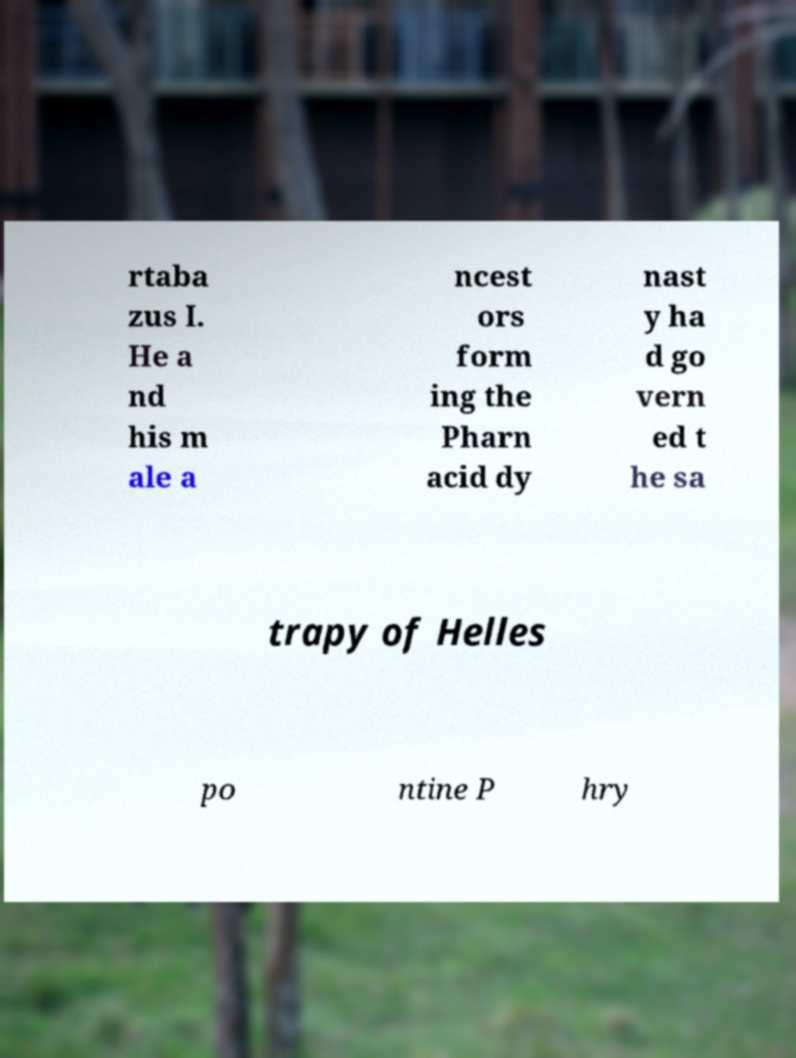Could you extract and type out the text from this image? rtaba zus I. He a nd his m ale a ncest ors form ing the Pharn acid dy nast y ha d go vern ed t he sa trapy of Helles po ntine P hry 